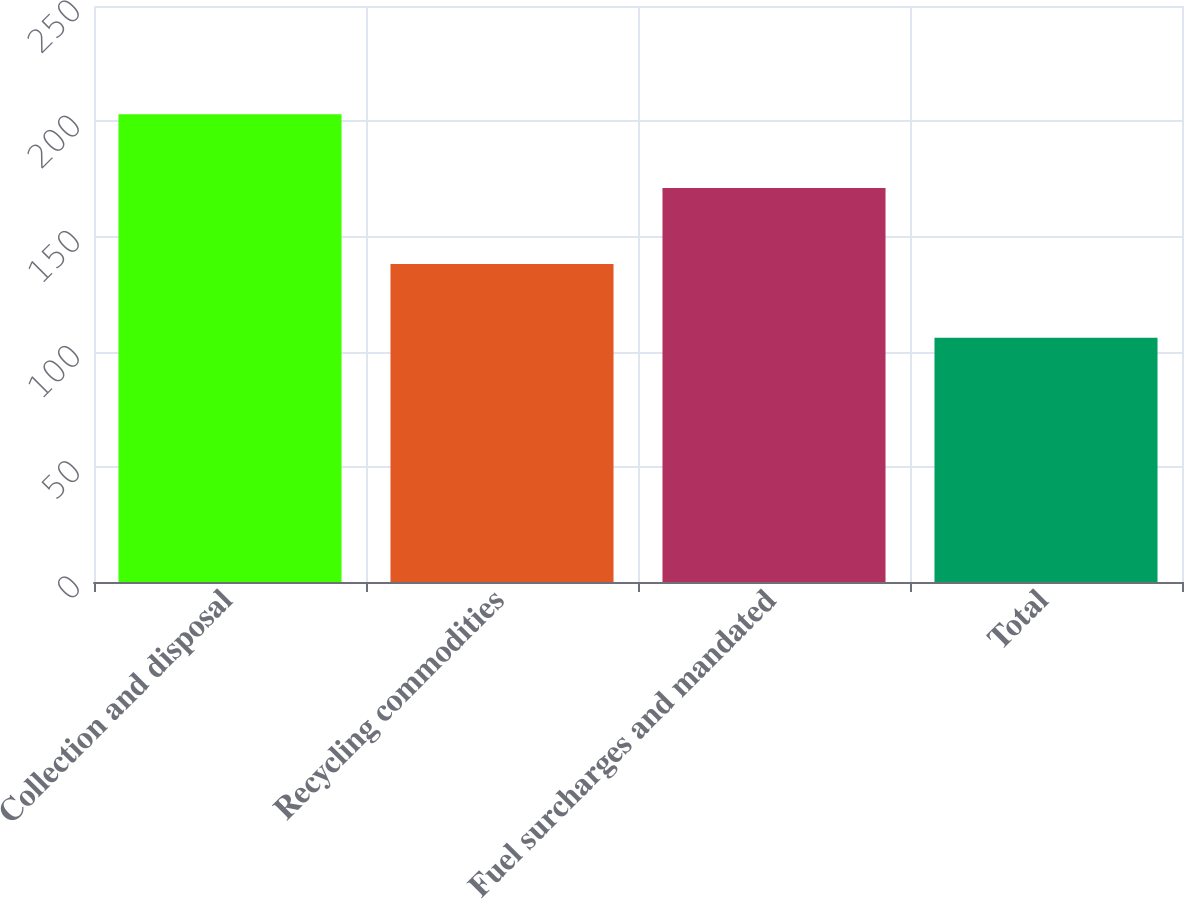<chart> <loc_0><loc_0><loc_500><loc_500><bar_chart><fcel>Collection and disposal<fcel>Recycling commodities<fcel>Fuel surcharges and mandated<fcel>Total<nl><fcel>203<fcel>138<fcel>171<fcel>106<nl></chart> 